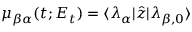Convert formula to latex. <formula><loc_0><loc_0><loc_500><loc_500>\mu _ { \beta \alpha } ( t ; E _ { t } ) = \langle \lambda _ { \alpha } | \hat { z } | \lambda _ { \beta , 0 } \rangle</formula> 